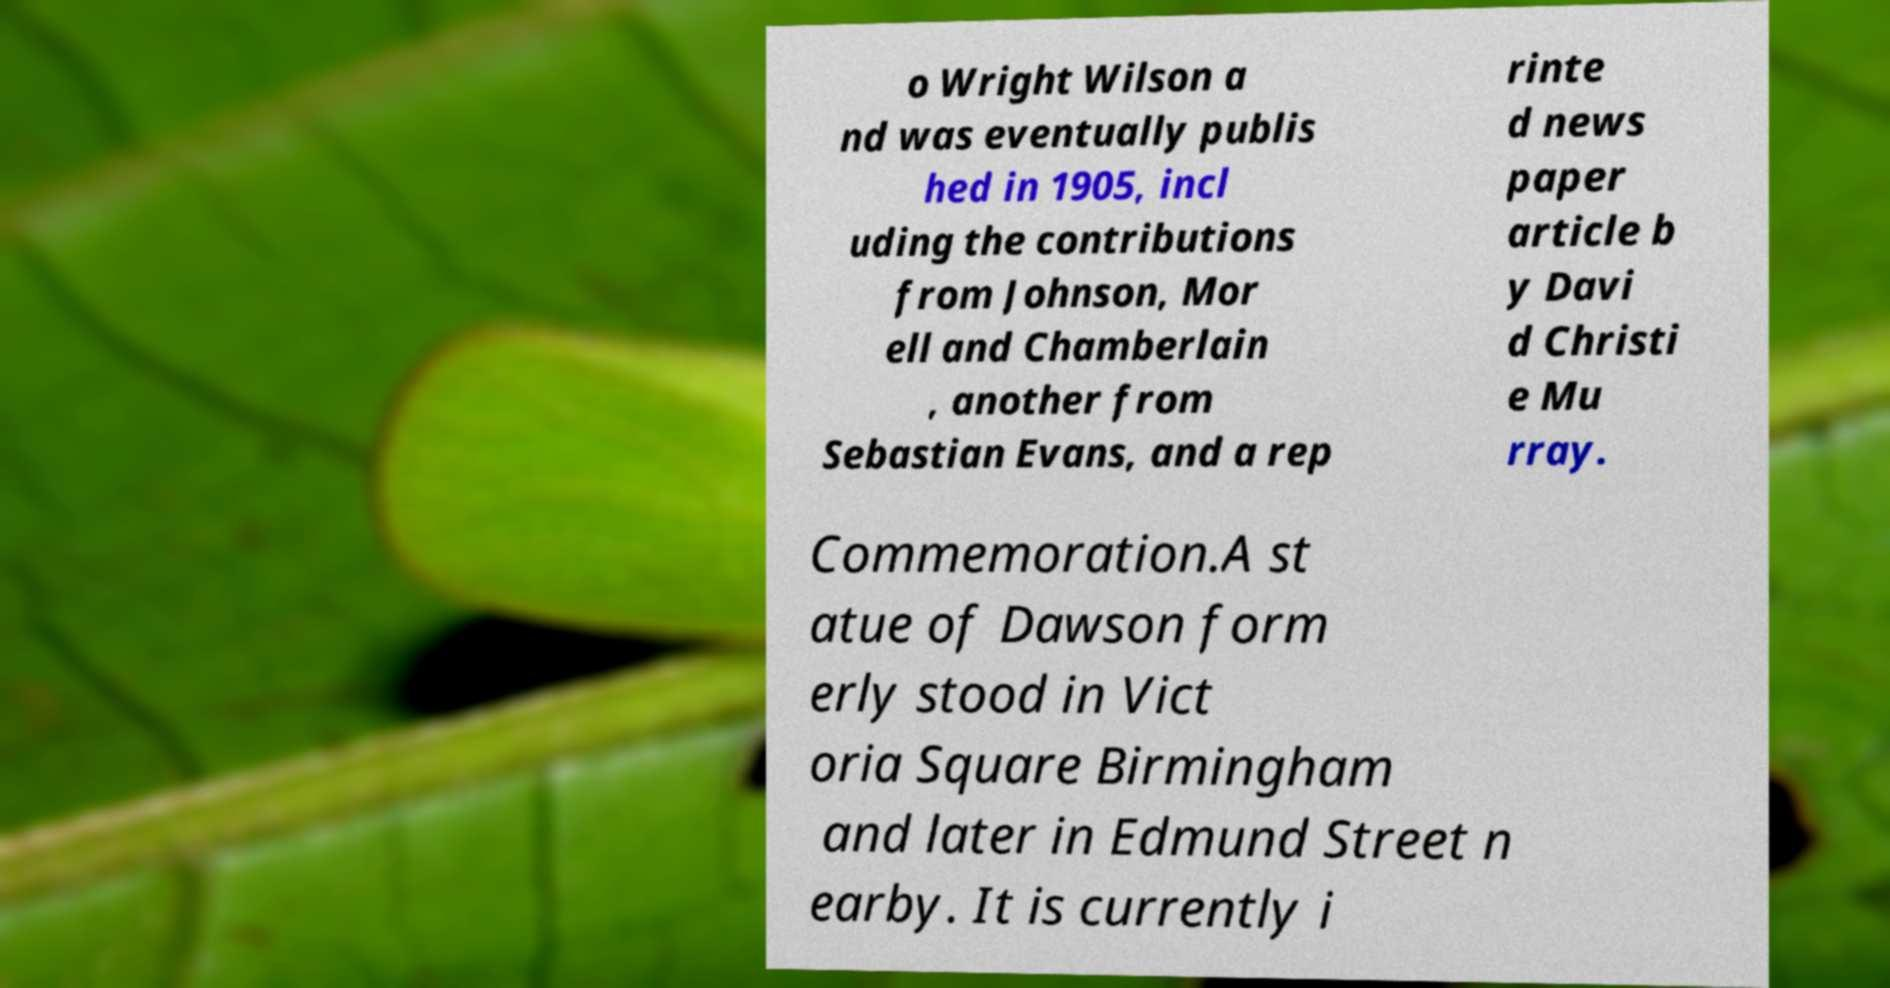Could you assist in decoding the text presented in this image and type it out clearly? o Wright Wilson a nd was eventually publis hed in 1905, incl uding the contributions from Johnson, Mor ell and Chamberlain , another from Sebastian Evans, and a rep rinte d news paper article b y Davi d Christi e Mu rray. Commemoration.A st atue of Dawson form erly stood in Vict oria Square Birmingham and later in Edmund Street n earby. It is currently i 